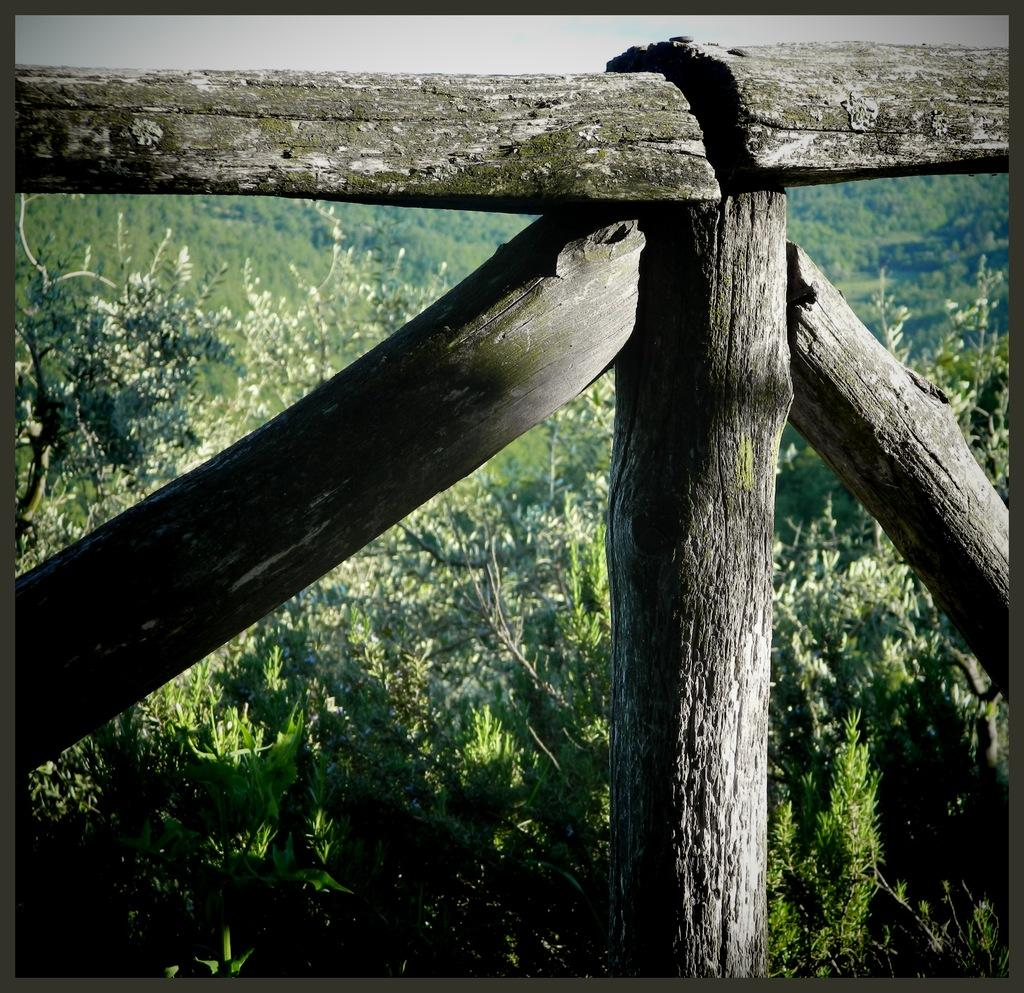What type of material is the railing made of in the image? The wooden railing in the image is made of wood. What can be seen in the background of the image? There are plants, trees, and the sky visible in the background of the image. What is the rate of the street in the image? There is no street present in the image, so it is not possible to determine the rate. 